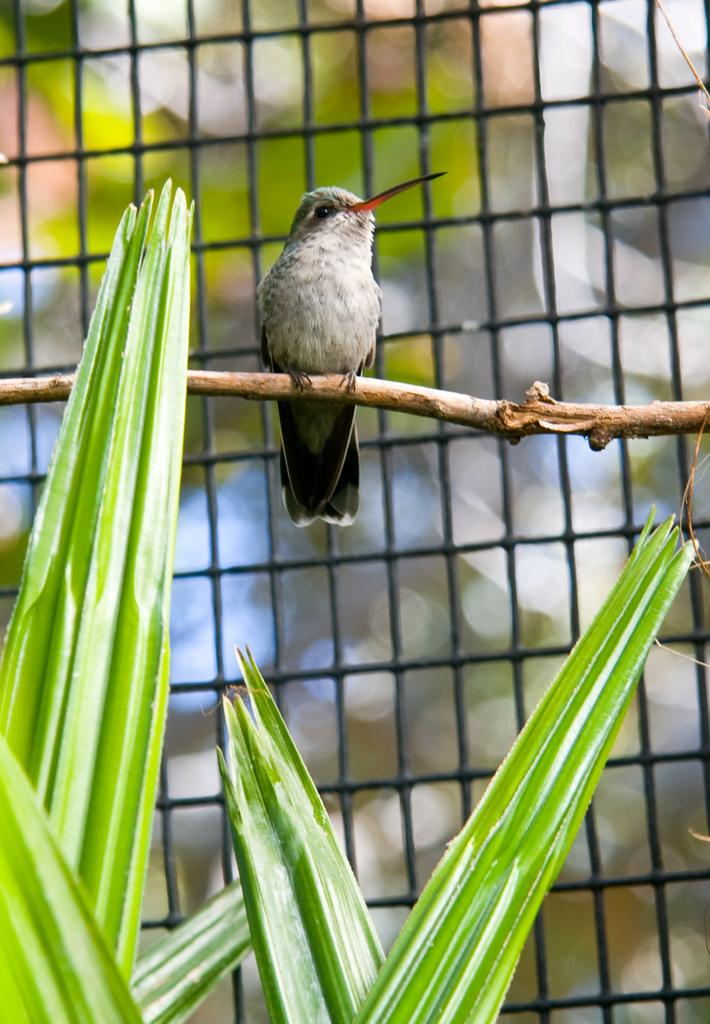What type of animal can be seen in the picture? There is a bird in the picture. What is the bird standing on? The bird is standing on a stick. What can be seen at the bottom of the image? Leaves are visible at the bottom of the image. What is in the background of the image? There is black fencing in the background of the image. Is there a mailbox present in the image? There is no mailbox visible in the image. Does the existence of the bird in the image prove the existence of all birds? No, the existence of the bird in the image does not prove the existence of all birds. Can you see a kitten playing with the bird in the image? There is no kitten present in the image, and the bird is standing on a stick, not interacting with any other animals. 